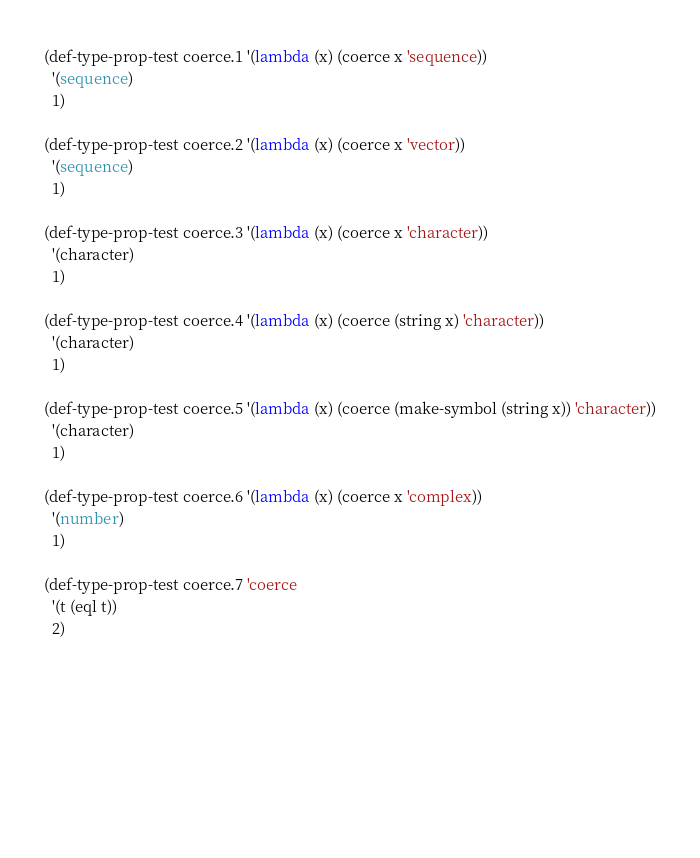<code> <loc_0><loc_0><loc_500><loc_500><_Lisp_>
(def-type-prop-test coerce.1 '(lambda (x) (coerce x 'sequence))
  '(sequence)
  1)

(def-type-prop-test coerce.2 '(lambda (x) (coerce x 'vector))
  '(sequence)
  1)

(def-type-prop-test coerce.3 '(lambda (x) (coerce x 'character))
  '(character)
  1)

(def-type-prop-test coerce.4 '(lambda (x) (coerce (string x) 'character))
  '(character)
  1)

(def-type-prop-test coerce.5 '(lambda (x) (coerce (make-symbol (string x)) 'character))
  '(character)
  1)

(def-type-prop-test coerce.6 '(lambda (x) (coerce x 'complex))
  '(number)
  1)

(def-type-prop-test coerce.7 'coerce
  '(t (eql t))
  2)







                    
</code> 